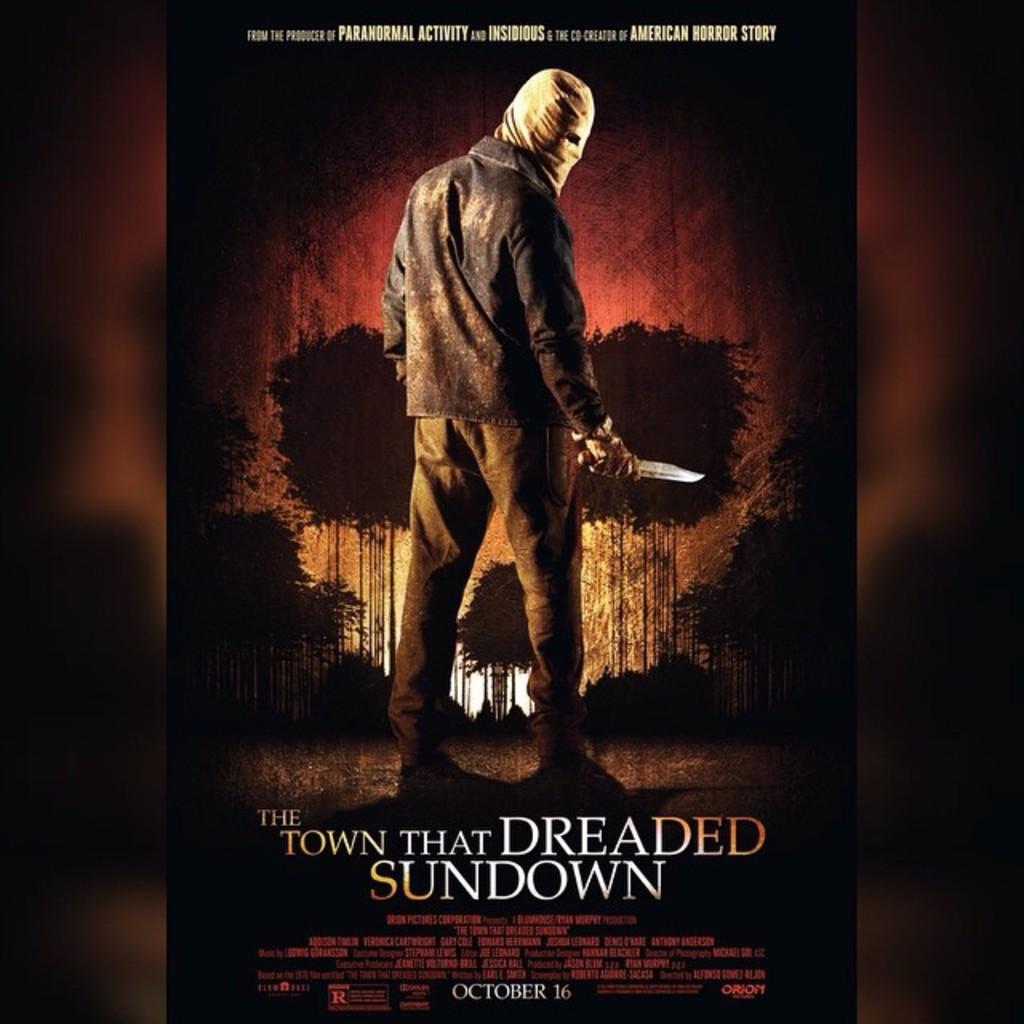What is the title of the movie?
Ensure brevity in your answer.  The town that dreaded sundown. 